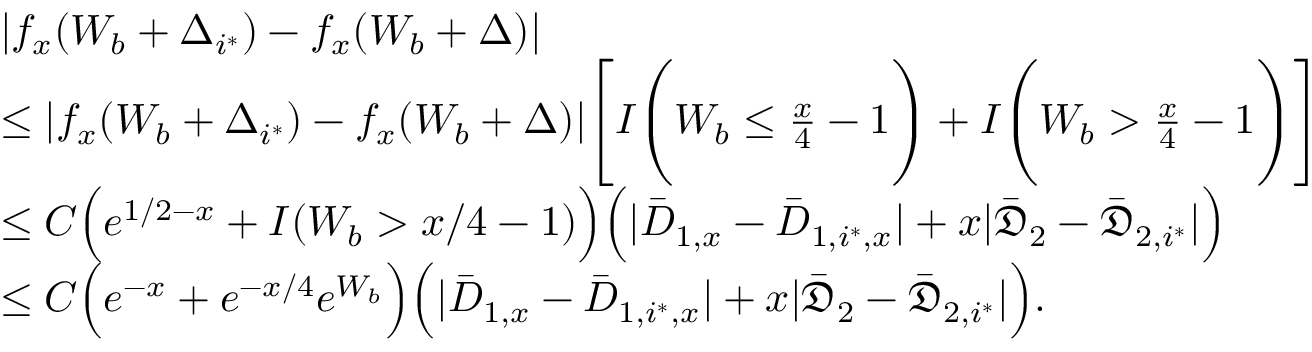<formula> <loc_0><loc_0><loc_500><loc_500>\begin{array} { r l } & { | f _ { x } ( W _ { b } + \Delta _ { i ^ { * } } ) - f _ { x } ( W _ { b } + \Delta ) | } \\ & { \leq | f _ { x } ( W _ { b } + \Delta _ { i ^ { * } } ) - f _ { x } ( W _ { b } + \Delta ) | \left [ I \left ( W _ { b } \leq \frac { x } { 4 } - 1 \right ) + I \left ( W _ { b } > \frac { x } { 4 } - 1 \right ) \right ] } \\ & { \leq C \left ( e ^ { 1 / 2 - x } + I ( W _ { b } > x / 4 - 1 ) \right ) \left ( | \bar { D } _ { 1 , x } - \bar { D } _ { 1 , i ^ { * } , x } | + x | \bar { \mathfrak { D } } _ { 2 } - \bar { \mathfrak { D } } _ { 2 , i ^ { * } } | \right ) } \\ & { \leq C \left ( e ^ { - x } + e ^ { - x / 4 } e ^ { W _ { b } } \right ) \left ( | \bar { D } _ { 1 , x } - \bar { D } _ { 1 , i ^ { * } , x } | + x | \bar { \mathfrak { D } } _ { 2 } - \bar { \mathfrak { D } } _ { 2 , i ^ { * } } | \right ) . } \end{array}</formula> 